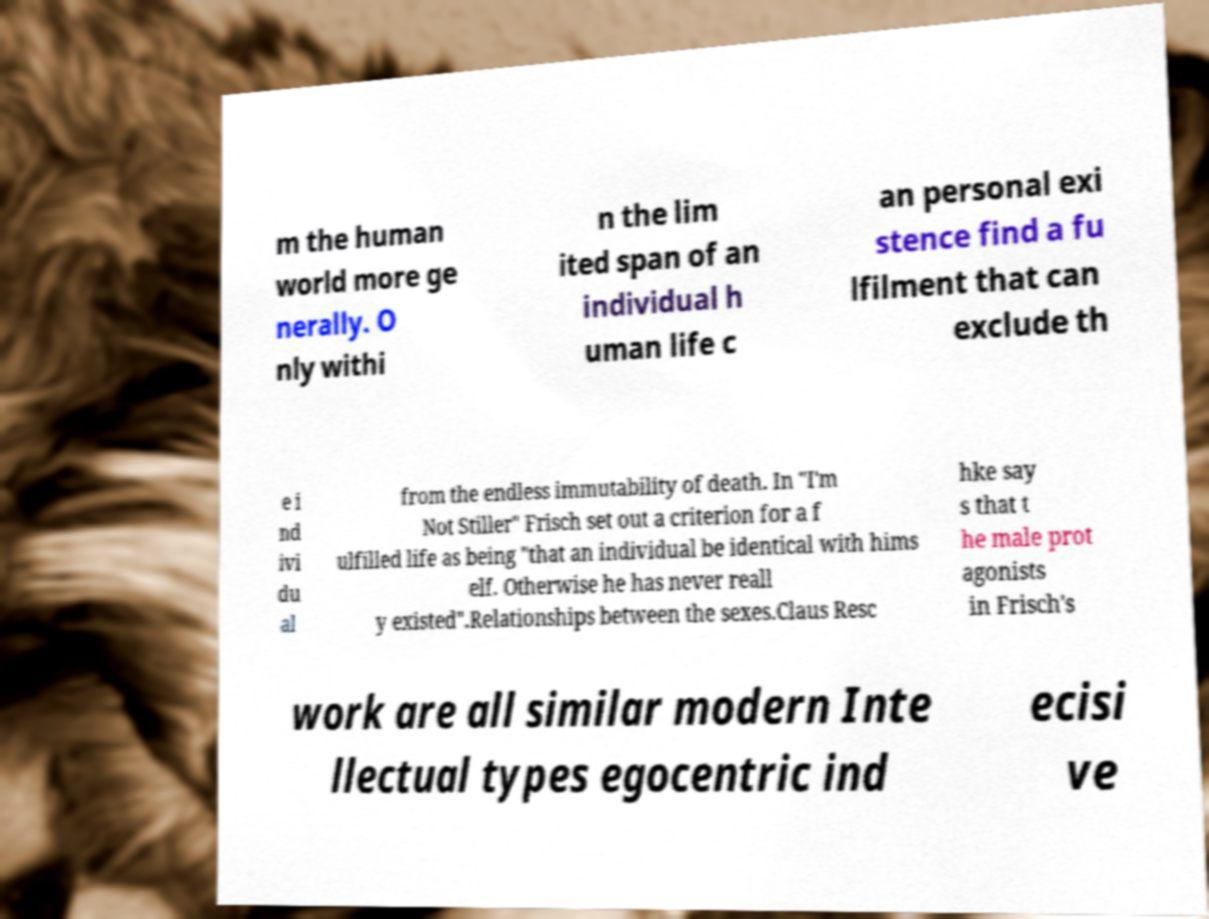For documentation purposes, I need the text within this image transcribed. Could you provide that? m the human world more ge nerally. O nly withi n the lim ited span of an individual h uman life c an personal exi stence find a fu lfilment that can exclude th e i nd ivi du al from the endless immutability of death. In "I'm Not Stiller" Frisch set out a criterion for a f ulfilled life as being "that an individual be identical with hims elf. Otherwise he has never reall y existed".Relationships between the sexes.Claus Resc hke say s that t he male prot agonists in Frisch's work are all similar modern Inte llectual types egocentric ind ecisi ve 